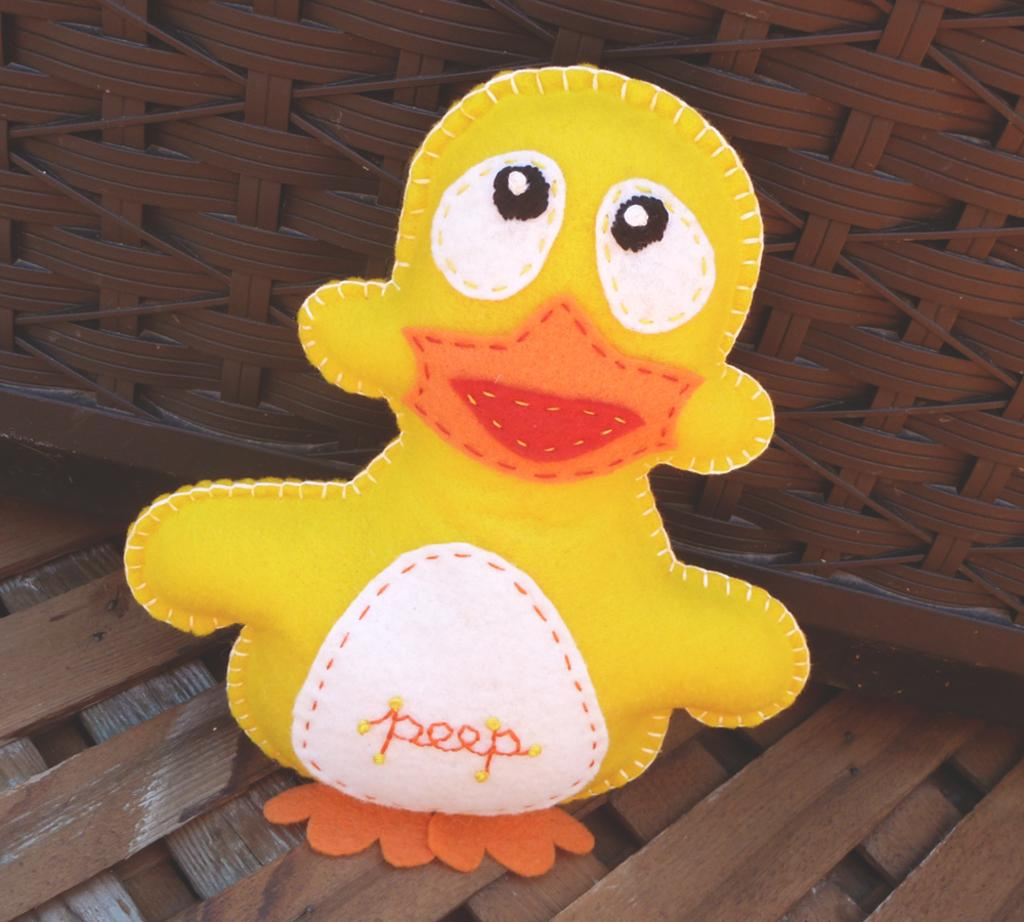What color is the doll in the image? The doll in the image is yellow-colored. Where is the doll located in the image? The doll is present on a bench. What type of oatmeal is the doll eating in the image? There is no oatmeal present in the image, and the doll is not eating anything. Can you tell me the name of the doll's aunt in the image? There is no information about the doll's family in the image, so we cannot determine the name of the doll's aunt. 